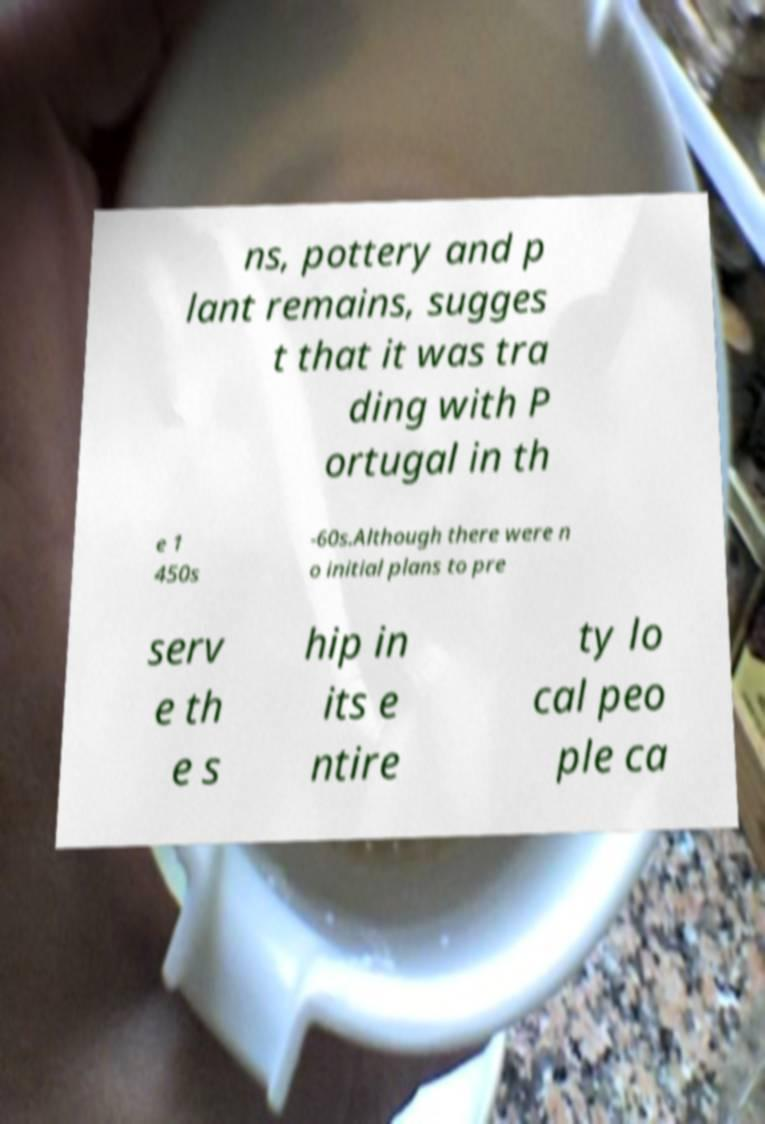Please identify and transcribe the text found in this image. ns, pottery and p lant remains, sugges t that it was tra ding with P ortugal in th e 1 450s -60s.Although there were n o initial plans to pre serv e th e s hip in its e ntire ty lo cal peo ple ca 